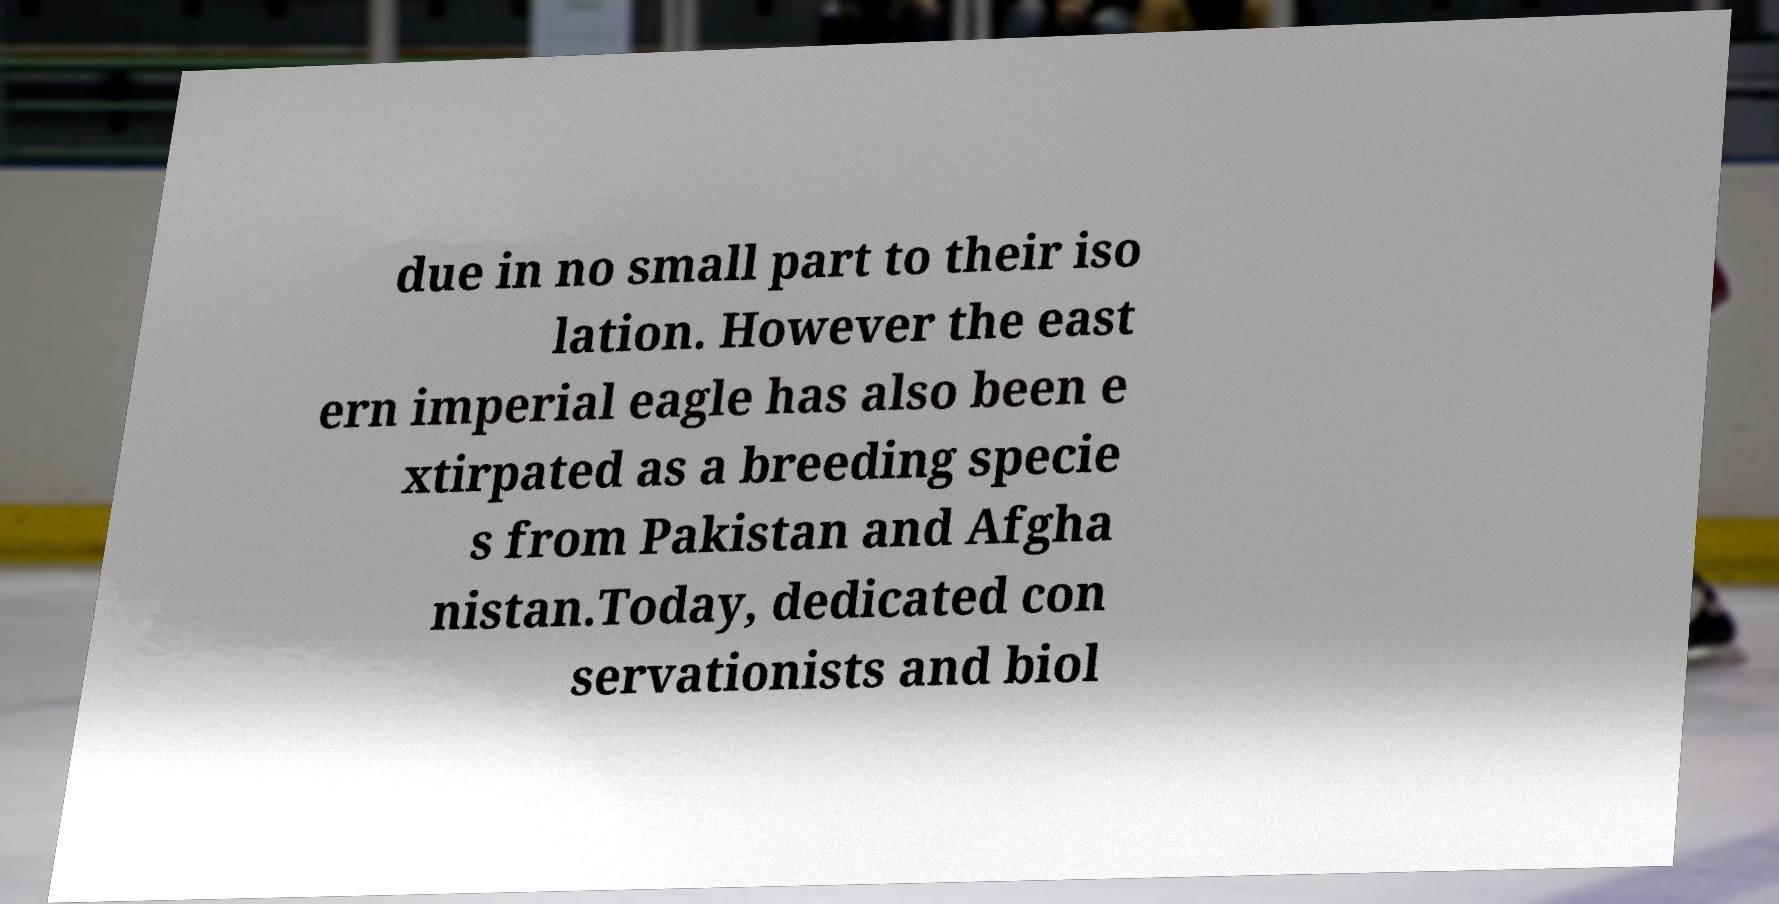For documentation purposes, I need the text within this image transcribed. Could you provide that? due in no small part to their iso lation. However the east ern imperial eagle has also been e xtirpated as a breeding specie s from Pakistan and Afgha nistan.Today, dedicated con servationists and biol 